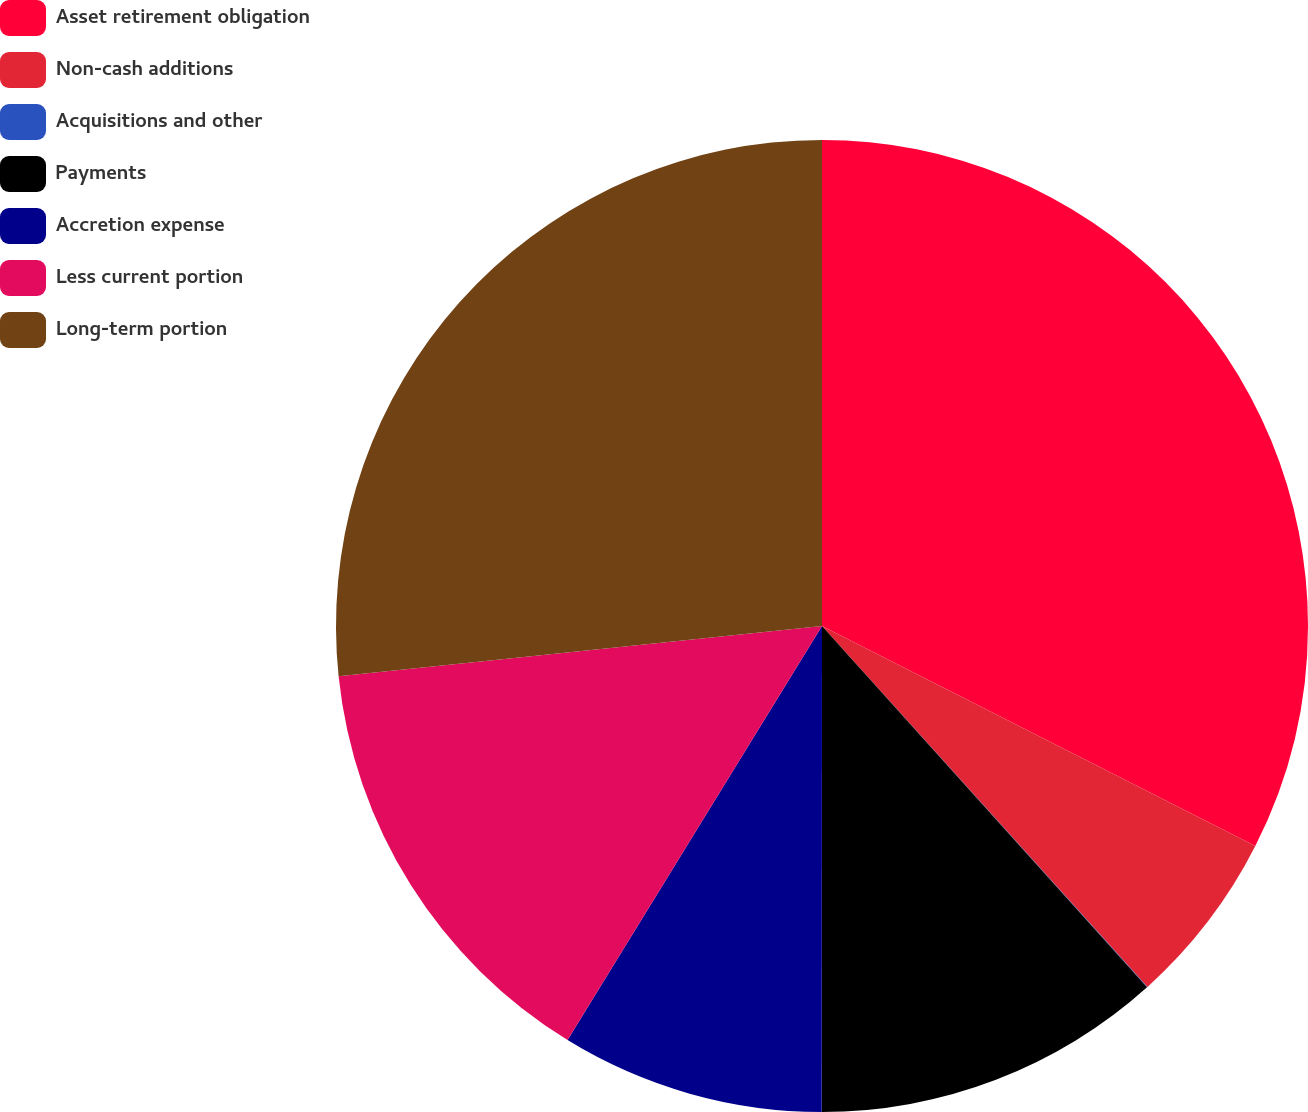Convert chart to OTSL. <chart><loc_0><loc_0><loc_500><loc_500><pie_chart><fcel>Asset retirement obligation<fcel>Non-cash additions<fcel>Acquisitions and other<fcel>Payments<fcel>Accretion expense<fcel>Less current portion<fcel>Long-term portion<nl><fcel>32.48%<fcel>5.84%<fcel>0.02%<fcel>11.67%<fcel>8.76%<fcel>14.58%<fcel>26.65%<nl></chart> 